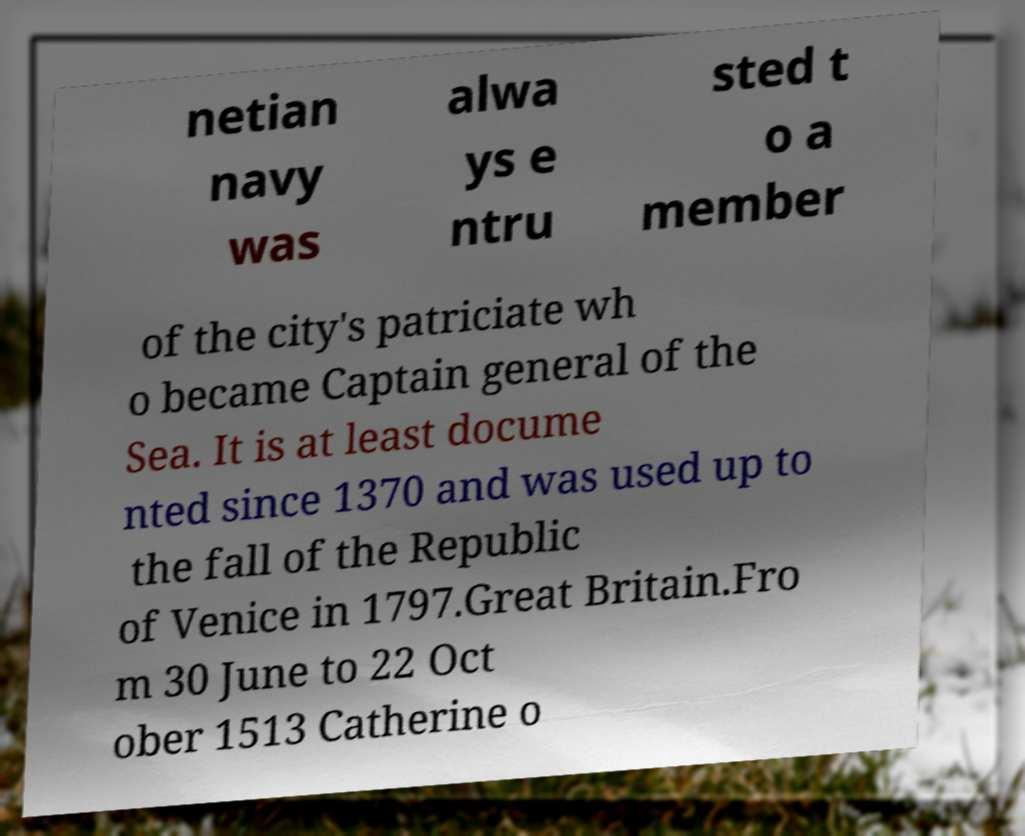I need the written content from this picture converted into text. Can you do that? netian navy was alwa ys e ntru sted t o a member of the city's patriciate wh o became Captain general of the Sea. It is at least docume nted since 1370 and was used up to the fall of the Republic of Venice in 1797.Great Britain.Fro m 30 June to 22 Oct ober 1513 Catherine o 